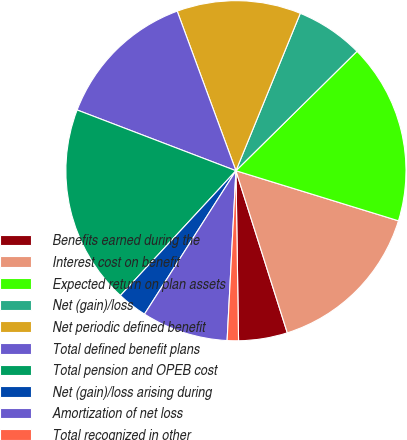<chart> <loc_0><loc_0><loc_500><loc_500><pie_chart><fcel>Benefits earned during the<fcel>Interest cost on benefit<fcel>Expected return on plan assets<fcel>Net (gain)/loss<fcel>Net periodic defined benefit<fcel>Total defined benefit plans<fcel>Total pension and OPEB cost<fcel>Net (gain)/loss arising during<fcel>Amortization of net loss<fcel>Total recognized in other<nl><fcel>4.64%<fcel>15.36%<fcel>17.15%<fcel>6.43%<fcel>11.79%<fcel>13.57%<fcel>18.93%<fcel>2.85%<fcel>8.21%<fcel>1.07%<nl></chart> 